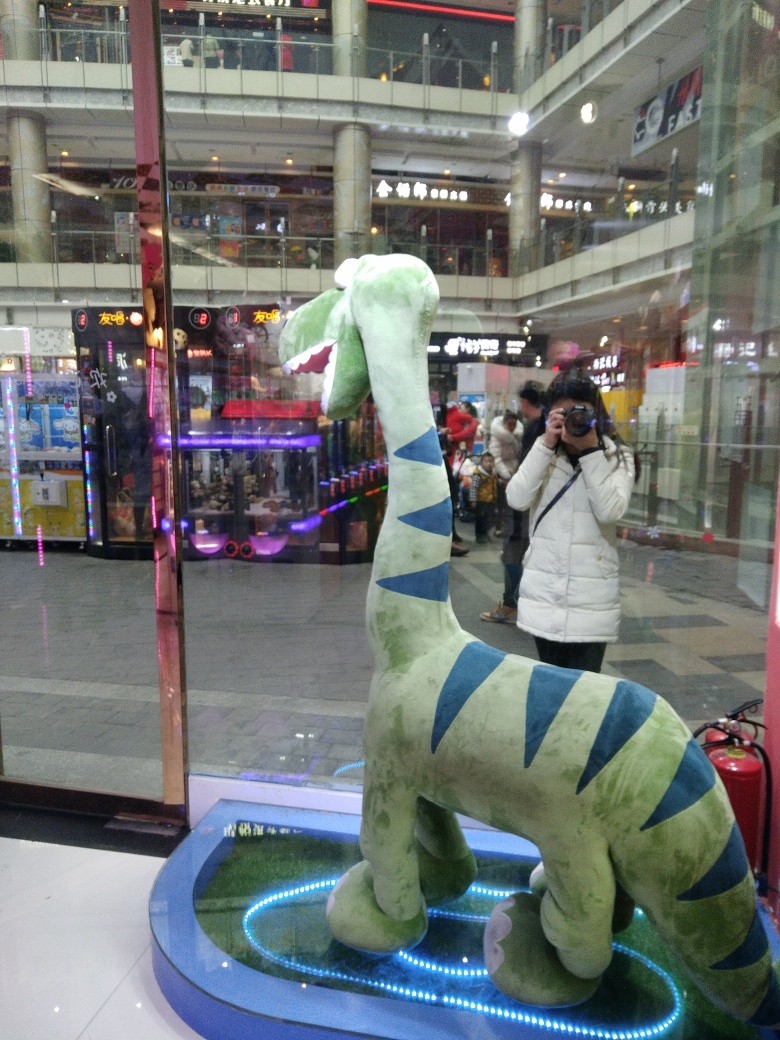Could you describe any symbolic meaning you interpret from this image with the plush dinosaur in focus? The plush dinosaur, with its pleasant demeanor set within an arcade, may symbolize the intersection of past and present. Dinosaurs, ancient and extinct, here are playfully reimagined for modern entertainment. This figure could be interpreted as a reminder to remain youthful at heart and to embrace the simple joys despite the complex, fast-paced world around us. What does the photographer's reflection in the glass add to the scene? The reflection of the photographer captures a layer of interaction between the viewer and the viewed. It's a meta-commentary of sorts, reflecting on the act of photography itself—how we engage with our surroundings and choose to frame our experiences. It adds a personal touch and highlights the idea of memory-making in a place meant for fun and games. 